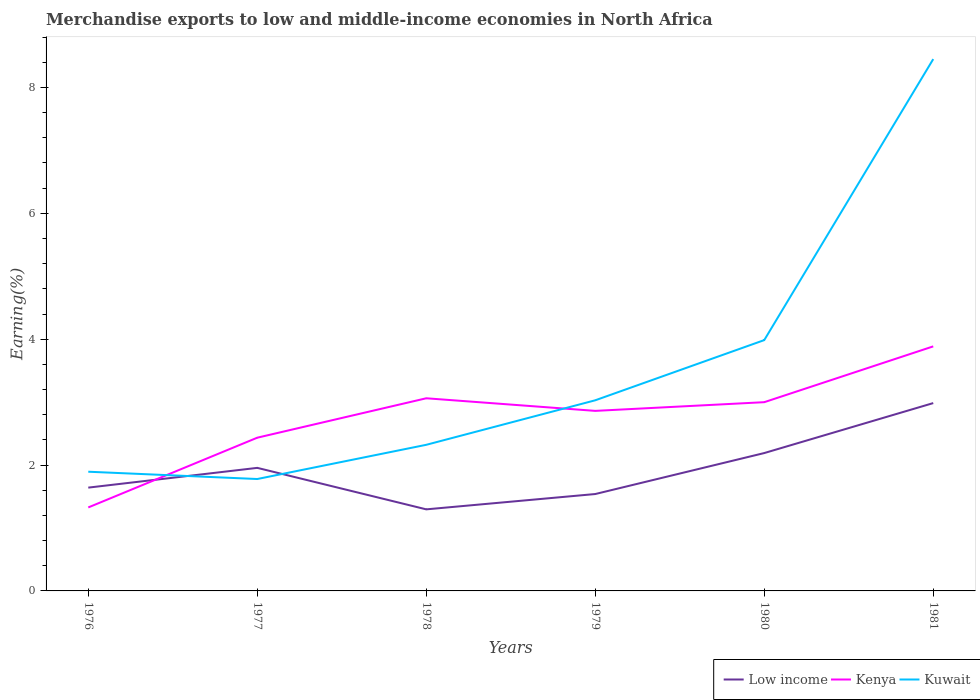How many different coloured lines are there?
Offer a terse response. 3. Does the line corresponding to Kenya intersect with the line corresponding to Kuwait?
Your answer should be very brief. Yes. Across all years, what is the maximum percentage of amount earned from merchandise exports in Kuwait?
Ensure brevity in your answer.  1.78. What is the total percentage of amount earned from merchandise exports in Low income in the graph?
Keep it short and to the point. 0.66. What is the difference between the highest and the second highest percentage of amount earned from merchandise exports in Kenya?
Offer a very short reply. 2.56. What is the difference between the highest and the lowest percentage of amount earned from merchandise exports in Kenya?
Your response must be concise. 4. Is the percentage of amount earned from merchandise exports in Kuwait strictly greater than the percentage of amount earned from merchandise exports in Kenya over the years?
Ensure brevity in your answer.  No. How many years are there in the graph?
Provide a succinct answer. 6. What is the difference between two consecutive major ticks on the Y-axis?
Your response must be concise. 2. Does the graph contain any zero values?
Provide a short and direct response. No. Where does the legend appear in the graph?
Keep it short and to the point. Bottom right. What is the title of the graph?
Provide a short and direct response. Merchandise exports to low and middle-income economies in North Africa. Does "Virgin Islands" appear as one of the legend labels in the graph?
Your answer should be very brief. No. What is the label or title of the X-axis?
Your response must be concise. Years. What is the label or title of the Y-axis?
Provide a short and direct response. Earning(%). What is the Earning(%) in Low income in 1976?
Your answer should be very brief. 1.64. What is the Earning(%) of Kenya in 1976?
Your answer should be compact. 1.33. What is the Earning(%) in Kuwait in 1976?
Ensure brevity in your answer.  1.89. What is the Earning(%) in Low income in 1977?
Offer a very short reply. 1.96. What is the Earning(%) of Kenya in 1977?
Keep it short and to the point. 2.43. What is the Earning(%) in Kuwait in 1977?
Offer a very short reply. 1.78. What is the Earning(%) in Low income in 1978?
Ensure brevity in your answer.  1.3. What is the Earning(%) in Kenya in 1978?
Ensure brevity in your answer.  3.06. What is the Earning(%) of Kuwait in 1978?
Your response must be concise. 2.32. What is the Earning(%) in Low income in 1979?
Ensure brevity in your answer.  1.54. What is the Earning(%) of Kenya in 1979?
Provide a succinct answer. 2.86. What is the Earning(%) of Kuwait in 1979?
Provide a succinct answer. 3.03. What is the Earning(%) of Low income in 1980?
Make the answer very short. 2.19. What is the Earning(%) of Kenya in 1980?
Your answer should be very brief. 3. What is the Earning(%) in Kuwait in 1980?
Offer a terse response. 3.99. What is the Earning(%) of Low income in 1981?
Your response must be concise. 2.98. What is the Earning(%) of Kenya in 1981?
Offer a very short reply. 3.89. What is the Earning(%) in Kuwait in 1981?
Your response must be concise. 8.45. Across all years, what is the maximum Earning(%) of Low income?
Your response must be concise. 2.98. Across all years, what is the maximum Earning(%) of Kenya?
Give a very brief answer. 3.89. Across all years, what is the maximum Earning(%) in Kuwait?
Make the answer very short. 8.45. Across all years, what is the minimum Earning(%) in Low income?
Your answer should be very brief. 1.3. Across all years, what is the minimum Earning(%) in Kenya?
Offer a terse response. 1.33. Across all years, what is the minimum Earning(%) of Kuwait?
Make the answer very short. 1.78. What is the total Earning(%) in Low income in the graph?
Give a very brief answer. 11.61. What is the total Earning(%) in Kenya in the graph?
Give a very brief answer. 16.57. What is the total Earning(%) of Kuwait in the graph?
Provide a short and direct response. 21.46. What is the difference between the Earning(%) in Low income in 1976 and that in 1977?
Make the answer very short. -0.31. What is the difference between the Earning(%) in Kenya in 1976 and that in 1977?
Your response must be concise. -1.11. What is the difference between the Earning(%) in Kuwait in 1976 and that in 1977?
Offer a terse response. 0.12. What is the difference between the Earning(%) in Low income in 1976 and that in 1978?
Your answer should be compact. 0.35. What is the difference between the Earning(%) of Kenya in 1976 and that in 1978?
Make the answer very short. -1.73. What is the difference between the Earning(%) of Kuwait in 1976 and that in 1978?
Your answer should be compact. -0.43. What is the difference between the Earning(%) in Low income in 1976 and that in 1979?
Your answer should be compact. 0.1. What is the difference between the Earning(%) of Kenya in 1976 and that in 1979?
Your response must be concise. -1.53. What is the difference between the Earning(%) of Kuwait in 1976 and that in 1979?
Keep it short and to the point. -1.13. What is the difference between the Earning(%) of Low income in 1976 and that in 1980?
Offer a terse response. -0.55. What is the difference between the Earning(%) in Kenya in 1976 and that in 1980?
Your response must be concise. -1.67. What is the difference between the Earning(%) in Kuwait in 1976 and that in 1980?
Ensure brevity in your answer.  -2.09. What is the difference between the Earning(%) of Low income in 1976 and that in 1981?
Offer a terse response. -1.34. What is the difference between the Earning(%) of Kenya in 1976 and that in 1981?
Your response must be concise. -2.56. What is the difference between the Earning(%) of Kuwait in 1976 and that in 1981?
Your answer should be compact. -6.56. What is the difference between the Earning(%) of Low income in 1977 and that in 1978?
Offer a very short reply. 0.66. What is the difference between the Earning(%) of Kenya in 1977 and that in 1978?
Provide a short and direct response. -0.63. What is the difference between the Earning(%) of Kuwait in 1977 and that in 1978?
Make the answer very short. -0.54. What is the difference between the Earning(%) of Low income in 1977 and that in 1979?
Make the answer very short. 0.42. What is the difference between the Earning(%) of Kenya in 1977 and that in 1979?
Make the answer very short. -0.43. What is the difference between the Earning(%) in Kuwait in 1977 and that in 1979?
Give a very brief answer. -1.25. What is the difference between the Earning(%) in Low income in 1977 and that in 1980?
Your answer should be very brief. -0.24. What is the difference between the Earning(%) in Kenya in 1977 and that in 1980?
Offer a terse response. -0.56. What is the difference between the Earning(%) of Kuwait in 1977 and that in 1980?
Keep it short and to the point. -2.21. What is the difference between the Earning(%) in Low income in 1977 and that in 1981?
Offer a terse response. -1.03. What is the difference between the Earning(%) in Kenya in 1977 and that in 1981?
Provide a succinct answer. -1.45. What is the difference between the Earning(%) of Kuwait in 1977 and that in 1981?
Offer a very short reply. -6.67. What is the difference between the Earning(%) in Low income in 1978 and that in 1979?
Keep it short and to the point. -0.24. What is the difference between the Earning(%) in Kenya in 1978 and that in 1979?
Give a very brief answer. 0.2. What is the difference between the Earning(%) in Kuwait in 1978 and that in 1979?
Provide a short and direct response. -0.71. What is the difference between the Earning(%) of Low income in 1978 and that in 1980?
Offer a very short reply. -0.89. What is the difference between the Earning(%) in Kenya in 1978 and that in 1980?
Make the answer very short. 0.06. What is the difference between the Earning(%) in Kuwait in 1978 and that in 1980?
Your response must be concise. -1.66. What is the difference between the Earning(%) of Low income in 1978 and that in 1981?
Provide a succinct answer. -1.69. What is the difference between the Earning(%) of Kenya in 1978 and that in 1981?
Make the answer very short. -0.82. What is the difference between the Earning(%) in Kuwait in 1978 and that in 1981?
Your response must be concise. -6.13. What is the difference between the Earning(%) in Low income in 1979 and that in 1980?
Ensure brevity in your answer.  -0.65. What is the difference between the Earning(%) of Kenya in 1979 and that in 1980?
Offer a terse response. -0.14. What is the difference between the Earning(%) in Kuwait in 1979 and that in 1980?
Your answer should be very brief. -0.96. What is the difference between the Earning(%) in Low income in 1979 and that in 1981?
Provide a short and direct response. -1.45. What is the difference between the Earning(%) of Kenya in 1979 and that in 1981?
Provide a short and direct response. -1.02. What is the difference between the Earning(%) of Kuwait in 1979 and that in 1981?
Provide a short and direct response. -5.42. What is the difference between the Earning(%) of Low income in 1980 and that in 1981?
Make the answer very short. -0.79. What is the difference between the Earning(%) of Kenya in 1980 and that in 1981?
Ensure brevity in your answer.  -0.89. What is the difference between the Earning(%) of Kuwait in 1980 and that in 1981?
Offer a terse response. -4.47. What is the difference between the Earning(%) of Low income in 1976 and the Earning(%) of Kenya in 1977?
Your response must be concise. -0.79. What is the difference between the Earning(%) in Low income in 1976 and the Earning(%) in Kuwait in 1977?
Ensure brevity in your answer.  -0.14. What is the difference between the Earning(%) in Kenya in 1976 and the Earning(%) in Kuwait in 1977?
Offer a terse response. -0.45. What is the difference between the Earning(%) in Low income in 1976 and the Earning(%) in Kenya in 1978?
Provide a short and direct response. -1.42. What is the difference between the Earning(%) in Low income in 1976 and the Earning(%) in Kuwait in 1978?
Make the answer very short. -0.68. What is the difference between the Earning(%) of Kenya in 1976 and the Earning(%) of Kuwait in 1978?
Offer a very short reply. -1. What is the difference between the Earning(%) in Low income in 1976 and the Earning(%) in Kenya in 1979?
Your response must be concise. -1.22. What is the difference between the Earning(%) of Low income in 1976 and the Earning(%) of Kuwait in 1979?
Make the answer very short. -1.39. What is the difference between the Earning(%) in Kenya in 1976 and the Earning(%) in Kuwait in 1979?
Your response must be concise. -1.7. What is the difference between the Earning(%) in Low income in 1976 and the Earning(%) in Kenya in 1980?
Ensure brevity in your answer.  -1.36. What is the difference between the Earning(%) of Low income in 1976 and the Earning(%) of Kuwait in 1980?
Make the answer very short. -2.34. What is the difference between the Earning(%) in Kenya in 1976 and the Earning(%) in Kuwait in 1980?
Make the answer very short. -2.66. What is the difference between the Earning(%) of Low income in 1976 and the Earning(%) of Kenya in 1981?
Your response must be concise. -2.24. What is the difference between the Earning(%) of Low income in 1976 and the Earning(%) of Kuwait in 1981?
Keep it short and to the point. -6.81. What is the difference between the Earning(%) in Kenya in 1976 and the Earning(%) in Kuwait in 1981?
Offer a terse response. -7.12. What is the difference between the Earning(%) in Low income in 1977 and the Earning(%) in Kenya in 1978?
Ensure brevity in your answer.  -1.11. What is the difference between the Earning(%) in Low income in 1977 and the Earning(%) in Kuwait in 1978?
Ensure brevity in your answer.  -0.37. What is the difference between the Earning(%) in Kenya in 1977 and the Earning(%) in Kuwait in 1978?
Ensure brevity in your answer.  0.11. What is the difference between the Earning(%) in Low income in 1977 and the Earning(%) in Kenya in 1979?
Offer a terse response. -0.91. What is the difference between the Earning(%) of Low income in 1977 and the Earning(%) of Kuwait in 1979?
Offer a terse response. -1.07. What is the difference between the Earning(%) of Kenya in 1977 and the Earning(%) of Kuwait in 1979?
Provide a succinct answer. -0.59. What is the difference between the Earning(%) in Low income in 1977 and the Earning(%) in Kenya in 1980?
Your response must be concise. -1.04. What is the difference between the Earning(%) of Low income in 1977 and the Earning(%) of Kuwait in 1980?
Give a very brief answer. -2.03. What is the difference between the Earning(%) of Kenya in 1977 and the Earning(%) of Kuwait in 1980?
Your answer should be very brief. -1.55. What is the difference between the Earning(%) in Low income in 1977 and the Earning(%) in Kenya in 1981?
Make the answer very short. -1.93. What is the difference between the Earning(%) in Low income in 1977 and the Earning(%) in Kuwait in 1981?
Give a very brief answer. -6.5. What is the difference between the Earning(%) in Kenya in 1977 and the Earning(%) in Kuwait in 1981?
Provide a short and direct response. -6.02. What is the difference between the Earning(%) in Low income in 1978 and the Earning(%) in Kenya in 1979?
Your response must be concise. -1.56. What is the difference between the Earning(%) in Low income in 1978 and the Earning(%) in Kuwait in 1979?
Your answer should be very brief. -1.73. What is the difference between the Earning(%) of Kenya in 1978 and the Earning(%) of Kuwait in 1979?
Offer a terse response. 0.03. What is the difference between the Earning(%) in Low income in 1978 and the Earning(%) in Kenya in 1980?
Ensure brevity in your answer.  -1.7. What is the difference between the Earning(%) of Low income in 1978 and the Earning(%) of Kuwait in 1980?
Make the answer very short. -2.69. What is the difference between the Earning(%) in Kenya in 1978 and the Earning(%) in Kuwait in 1980?
Offer a very short reply. -0.92. What is the difference between the Earning(%) of Low income in 1978 and the Earning(%) of Kenya in 1981?
Provide a succinct answer. -2.59. What is the difference between the Earning(%) in Low income in 1978 and the Earning(%) in Kuwait in 1981?
Provide a succinct answer. -7.15. What is the difference between the Earning(%) of Kenya in 1978 and the Earning(%) of Kuwait in 1981?
Give a very brief answer. -5.39. What is the difference between the Earning(%) of Low income in 1979 and the Earning(%) of Kenya in 1980?
Provide a succinct answer. -1.46. What is the difference between the Earning(%) of Low income in 1979 and the Earning(%) of Kuwait in 1980?
Give a very brief answer. -2.45. What is the difference between the Earning(%) of Kenya in 1979 and the Earning(%) of Kuwait in 1980?
Make the answer very short. -1.12. What is the difference between the Earning(%) of Low income in 1979 and the Earning(%) of Kenya in 1981?
Ensure brevity in your answer.  -2.35. What is the difference between the Earning(%) of Low income in 1979 and the Earning(%) of Kuwait in 1981?
Your response must be concise. -6.91. What is the difference between the Earning(%) in Kenya in 1979 and the Earning(%) in Kuwait in 1981?
Give a very brief answer. -5.59. What is the difference between the Earning(%) in Low income in 1980 and the Earning(%) in Kenya in 1981?
Provide a short and direct response. -1.7. What is the difference between the Earning(%) of Low income in 1980 and the Earning(%) of Kuwait in 1981?
Ensure brevity in your answer.  -6.26. What is the difference between the Earning(%) in Kenya in 1980 and the Earning(%) in Kuwait in 1981?
Your answer should be compact. -5.45. What is the average Earning(%) in Low income per year?
Your answer should be compact. 1.93. What is the average Earning(%) in Kenya per year?
Your answer should be compact. 2.76. What is the average Earning(%) of Kuwait per year?
Make the answer very short. 3.58. In the year 1976, what is the difference between the Earning(%) in Low income and Earning(%) in Kenya?
Your response must be concise. 0.31. In the year 1976, what is the difference between the Earning(%) of Low income and Earning(%) of Kuwait?
Keep it short and to the point. -0.25. In the year 1976, what is the difference between the Earning(%) in Kenya and Earning(%) in Kuwait?
Your answer should be very brief. -0.57. In the year 1977, what is the difference between the Earning(%) in Low income and Earning(%) in Kenya?
Your answer should be very brief. -0.48. In the year 1977, what is the difference between the Earning(%) in Low income and Earning(%) in Kuwait?
Make the answer very short. 0.18. In the year 1977, what is the difference between the Earning(%) of Kenya and Earning(%) of Kuwait?
Keep it short and to the point. 0.66. In the year 1978, what is the difference between the Earning(%) in Low income and Earning(%) in Kenya?
Make the answer very short. -1.77. In the year 1978, what is the difference between the Earning(%) in Low income and Earning(%) in Kuwait?
Give a very brief answer. -1.03. In the year 1978, what is the difference between the Earning(%) of Kenya and Earning(%) of Kuwait?
Your answer should be compact. 0.74. In the year 1979, what is the difference between the Earning(%) of Low income and Earning(%) of Kenya?
Provide a short and direct response. -1.32. In the year 1979, what is the difference between the Earning(%) of Low income and Earning(%) of Kuwait?
Keep it short and to the point. -1.49. In the year 1979, what is the difference between the Earning(%) of Kenya and Earning(%) of Kuwait?
Ensure brevity in your answer.  -0.17. In the year 1980, what is the difference between the Earning(%) in Low income and Earning(%) in Kenya?
Your answer should be compact. -0.81. In the year 1980, what is the difference between the Earning(%) of Low income and Earning(%) of Kuwait?
Give a very brief answer. -1.79. In the year 1980, what is the difference between the Earning(%) of Kenya and Earning(%) of Kuwait?
Offer a very short reply. -0.99. In the year 1981, what is the difference between the Earning(%) of Low income and Earning(%) of Kenya?
Make the answer very short. -0.9. In the year 1981, what is the difference between the Earning(%) of Low income and Earning(%) of Kuwait?
Ensure brevity in your answer.  -5.47. In the year 1981, what is the difference between the Earning(%) in Kenya and Earning(%) in Kuwait?
Keep it short and to the point. -4.57. What is the ratio of the Earning(%) in Low income in 1976 to that in 1977?
Make the answer very short. 0.84. What is the ratio of the Earning(%) of Kenya in 1976 to that in 1977?
Provide a succinct answer. 0.54. What is the ratio of the Earning(%) of Kuwait in 1976 to that in 1977?
Ensure brevity in your answer.  1.07. What is the ratio of the Earning(%) of Low income in 1976 to that in 1978?
Your answer should be very brief. 1.27. What is the ratio of the Earning(%) of Kenya in 1976 to that in 1978?
Give a very brief answer. 0.43. What is the ratio of the Earning(%) of Kuwait in 1976 to that in 1978?
Offer a terse response. 0.82. What is the ratio of the Earning(%) in Low income in 1976 to that in 1979?
Offer a very short reply. 1.07. What is the ratio of the Earning(%) in Kenya in 1976 to that in 1979?
Offer a very short reply. 0.46. What is the ratio of the Earning(%) of Kuwait in 1976 to that in 1979?
Keep it short and to the point. 0.63. What is the ratio of the Earning(%) in Low income in 1976 to that in 1980?
Offer a very short reply. 0.75. What is the ratio of the Earning(%) of Kenya in 1976 to that in 1980?
Provide a short and direct response. 0.44. What is the ratio of the Earning(%) in Kuwait in 1976 to that in 1980?
Your answer should be very brief. 0.48. What is the ratio of the Earning(%) in Low income in 1976 to that in 1981?
Provide a short and direct response. 0.55. What is the ratio of the Earning(%) of Kenya in 1976 to that in 1981?
Provide a succinct answer. 0.34. What is the ratio of the Earning(%) in Kuwait in 1976 to that in 1981?
Provide a short and direct response. 0.22. What is the ratio of the Earning(%) of Low income in 1977 to that in 1978?
Make the answer very short. 1.51. What is the ratio of the Earning(%) of Kenya in 1977 to that in 1978?
Your answer should be compact. 0.8. What is the ratio of the Earning(%) in Kuwait in 1977 to that in 1978?
Your response must be concise. 0.77. What is the ratio of the Earning(%) of Low income in 1977 to that in 1979?
Your response must be concise. 1.27. What is the ratio of the Earning(%) in Kenya in 1977 to that in 1979?
Your response must be concise. 0.85. What is the ratio of the Earning(%) in Kuwait in 1977 to that in 1979?
Offer a terse response. 0.59. What is the ratio of the Earning(%) of Low income in 1977 to that in 1980?
Provide a short and direct response. 0.89. What is the ratio of the Earning(%) of Kenya in 1977 to that in 1980?
Ensure brevity in your answer.  0.81. What is the ratio of the Earning(%) of Kuwait in 1977 to that in 1980?
Ensure brevity in your answer.  0.45. What is the ratio of the Earning(%) of Low income in 1977 to that in 1981?
Your answer should be compact. 0.66. What is the ratio of the Earning(%) of Kenya in 1977 to that in 1981?
Offer a very short reply. 0.63. What is the ratio of the Earning(%) of Kuwait in 1977 to that in 1981?
Offer a terse response. 0.21. What is the ratio of the Earning(%) of Low income in 1978 to that in 1979?
Keep it short and to the point. 0.84. What is the ratio of the Earning(%) of Kenya in 1978 to that in 1979?
Keep it short and to the point. 1.07. What is the ratio of the Earning(%) in Kuwait in 1978 to that in 1979?
Offer a very short reply. 0.77. What is the ratio of the Earning(%) of Low income in 1978 to that in 1980?
Keep it short and to the point. 0.59. What is the ratio of the Earning(%) in Kenya in 1978 to that in 1980?
Ensure brevity in your answer.  1.02. What is the ratio of the Earning(%) of Kuwait in 1978 to that in 1980?
Your answer should be compact. 0.58. What is the ratio of the Earning(%) in Low income in 1978 to that in 1981?
Keep it short and to the point. 0.43. What is the ratio of the Earning(%) in Kenya in 1978 to that in 1981?
Your answer should be compact. 0.79. What is the ratio of the Earning(%) of Kuwait in 1978 to that in 1981?
Provide a short and direct response. 0.27. What is the ratio of the Earning(%) of Low income in 1979 to that in 1980?
Offer a very short reply. 0.7. What is the ratio of the Earning(%) in Kenya in 1979 to that in 1980?
Provide a succinct answer. 0.95. What is the ratio of the Earning(%) of Kuwait in 1979 to that in 1980?
Make the answer very short. 0.76. What is the ratio of the Earning(%) of Low income in 1979 to that in 1981?
Keep it short and to the point. 0.52. What is the ratio of the Earning(%) of Kenya in 1979 to that in 1981?
Provide a succinct answer. 0.74. What is the ratio of the Earning(%) in Kuwait in 1979 to that in 1981?
Your response must be concise. 0.36. What is the ratio of the Earning(%) in Low income in 1980 to that in 1981?
Your answer should be compact. 0.73. What is the ratio of the Earning(%) in Kenya in 1980 to that in 1981?
Provide a succinct answer. 0.77. What is the ratio of the Earning(%) of Kuwait in 1980 to that in 1981?
Ensure brevity in your answer.  0.47. What is the difference between the highest and the second highest Earning(%) in Low income?
Keep it short and to the point. 0.79. What is the difference between the highest and the second highest Earning(%) of Kenya?
Your answer should be very brief. 0.82. What is the difference between the highest and the second highest Earning(%) in Kuwait?
Ensure brevity in your answer.  4.47. What is the difference between the highest and the lowest Earning(%) in Low income?
Your response must be concise. 1.69. What is the difference between the highest and the lowest Earning(%) of Kenya?
Keep it short and to the point. 2.56. What is the difference between the highest and the lowest Earning(%) in Kuwait?
Your response must be concise. 6.67. 